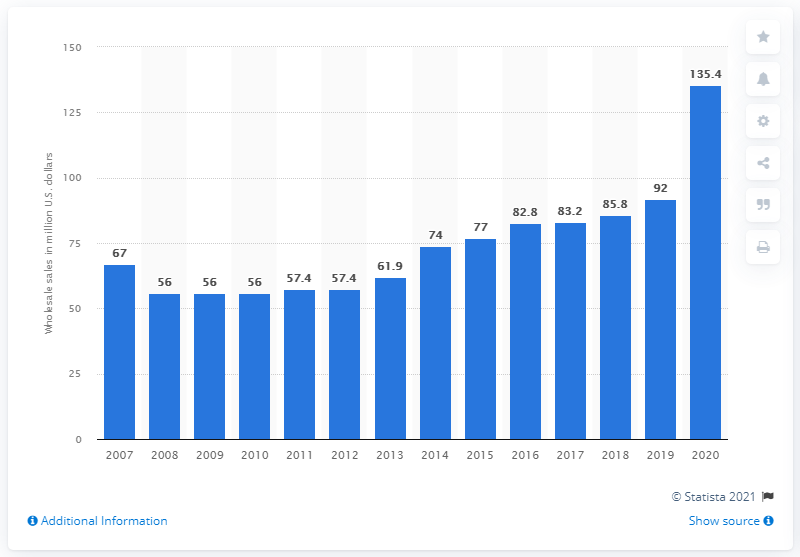Mention a couple of crucial points in this snapshot. In 2020, the sales of rowing machines reached a total of 135.4 million dollars. 